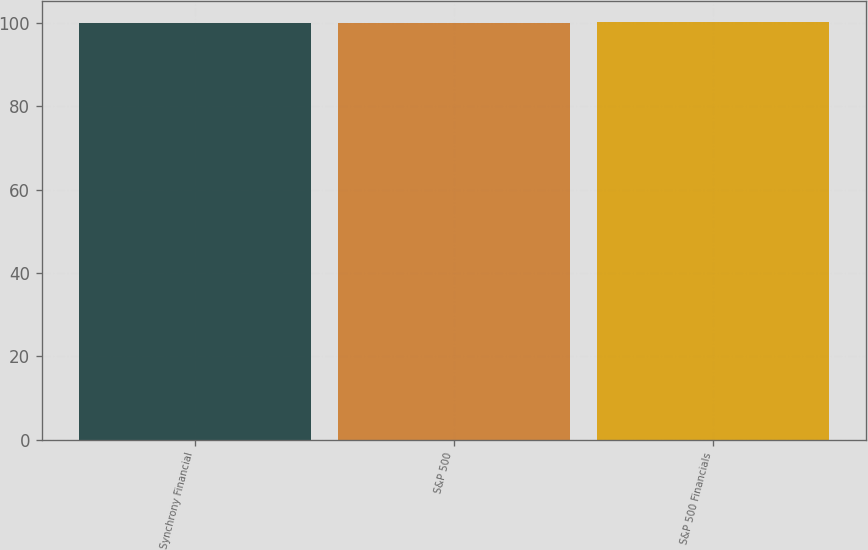Convert chart. <chart><loc_0><loc_0><loc_500><loc_500><bar_chart><fcel>Synchrony Financial<fcel>S&P 500<fcel>S&P 500 Financials<nl><fcel>100<fcel>100.1<fcel>100.2<nl></chart> 